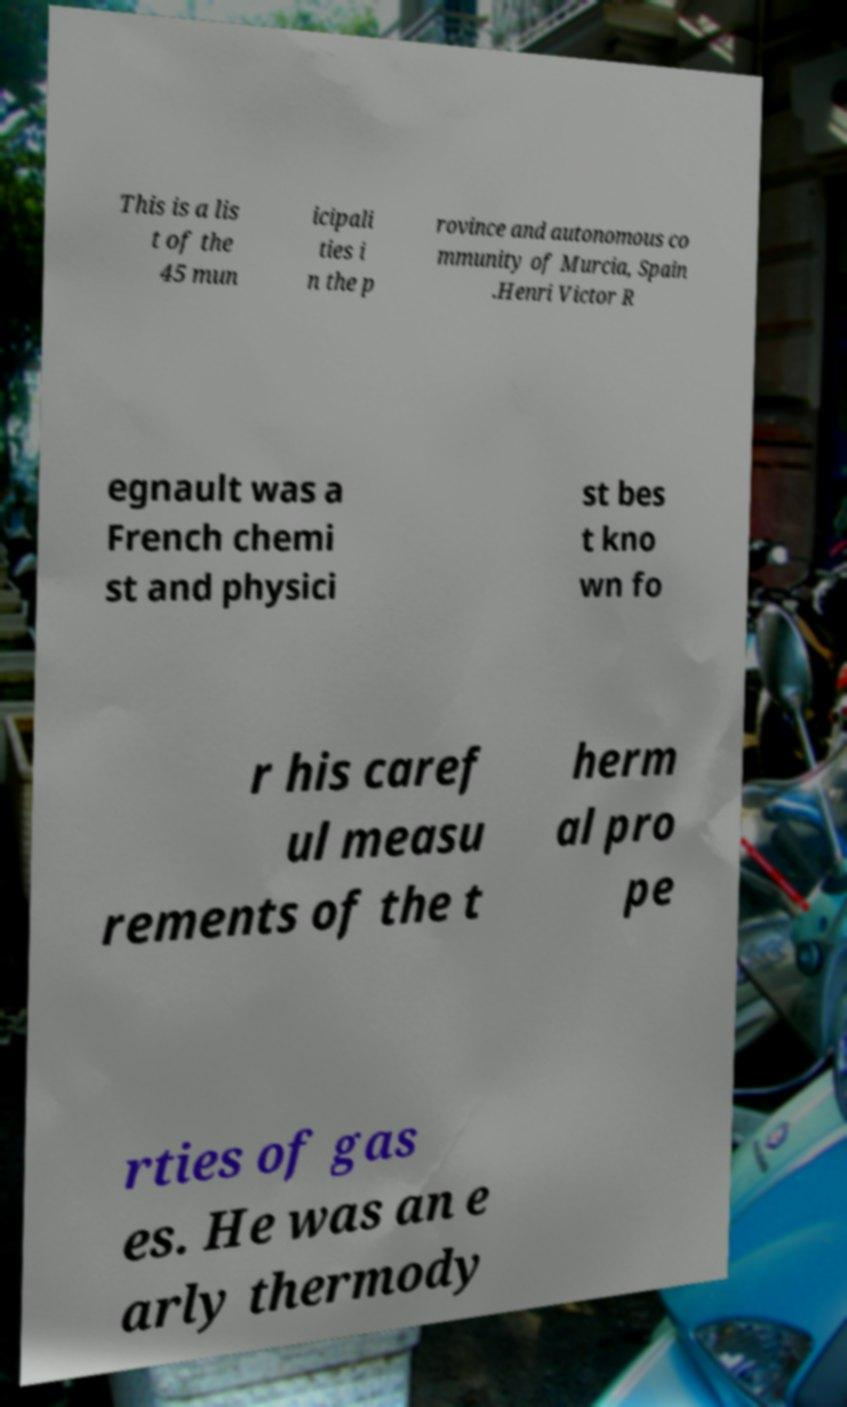I need the written content from this picture converted into text. Can you do that? This is a lis t of the 45 mun icipali ties i n the p rovince and autonomous co mmunity of Murcia, Spain .Henri Victor R egnault was a French chemi st and physici st bes t kno wn fo r his caref ul measu rements of the t herm al pro pe rties of gas es. He was an e arly thermody 